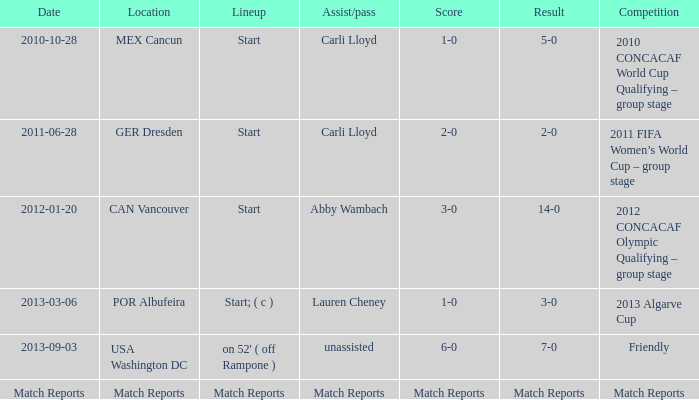What score does a competition have in terms of match reports? Match Reports. 